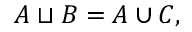Convert formula to latex. <formula><loc_0><loc_0><loc_500><loc_500>A \sqcup B = A \cup C ,</formula> 